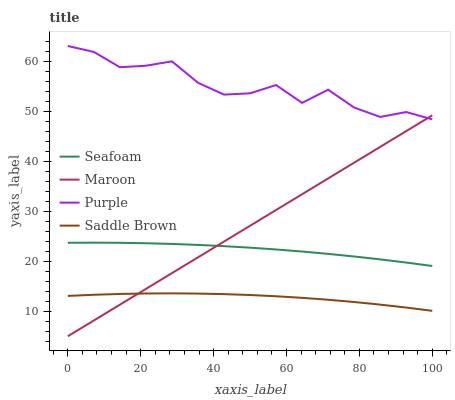Does Saddle Brown have the minimum area under the curve?
Answer yes or no. Yes. Does Purple have the maximum area under the curve?
Answer yes or no. Yes. Does Seafoam have the minimum area under the curve?
Answer yes or no. No. Does Seafoam have the maximum area under the curve?
Answer yes or no. No. Is Maroon the smoothest?
Answer yes or no. Yes. Is Purple the roughest?
Answer yes or no. Yes. Is Seafoam the smoothest?
Answer yes or no. No. Is Seafoam the roughest?
Answer yes or no. No. Does Seafoam have the lowest value?
Answer yes or no. No. Does Seafoam have the highest value?
Answer yes or no. No. Is Saddle Brown less than Purple?
Answer yes or no. Yes. Is Seafoam greater than Saddle Brown?
Answer yes or no. Yes. Does Saddle Brown intersect Purple?
Answer yes or no. No. 